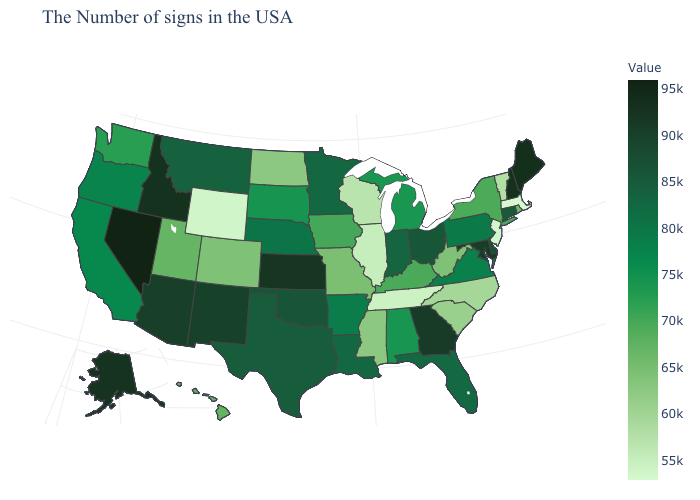Among the states that border Delaware , does New Jersey have the lowest value?
Give a very brief answer. Yes. Does Wisconsin have a higher value than Maine?
Write a very short answer. No. Does Alabama have the highest value in the South?
Be succinct. No. Among the states that border Idaho , does Wyoming have the lowest value?
Be succinct. Yes. Does Mississippi have the lowest value in the South?
Concise answer only. No. Which states hav the highest value in the Northeast?
Concise answer only. Maine. Among the states that border Delaware , does New Jersey have the highest value?
Quick response, please. No. Among the states that border Nebraska , does Colorado have the highest value?
Concise answer only. No. Among the states that border Idaho , does Wyoming have the lowest value?
Give a very brief answer. Yes. 